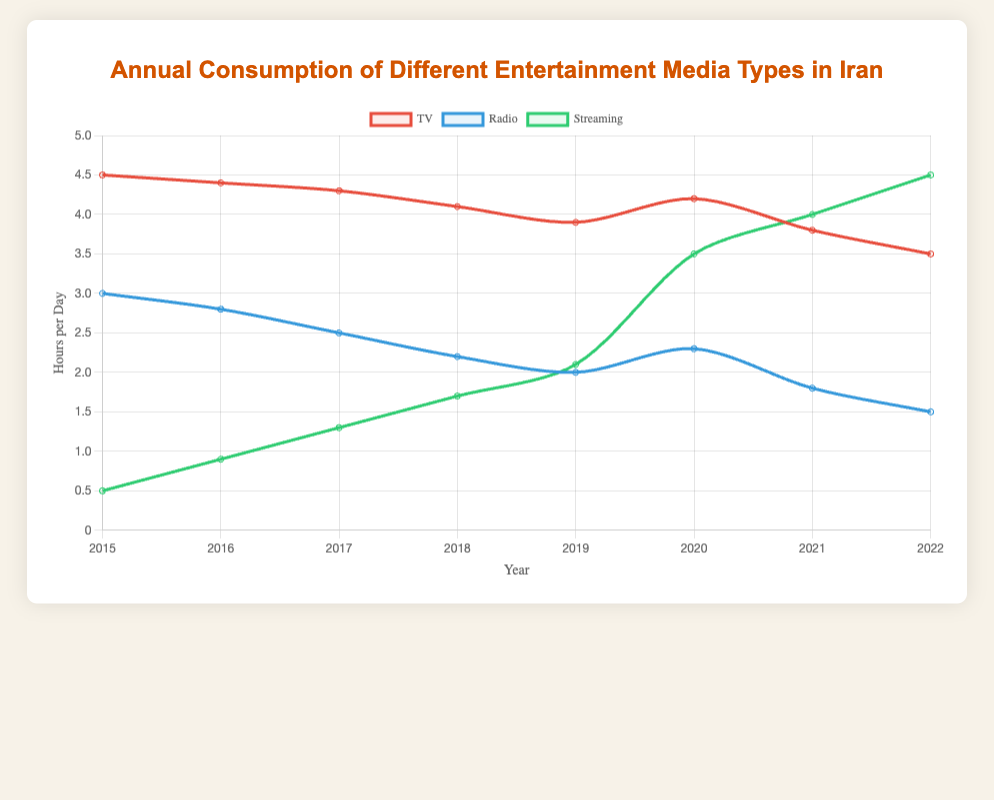what was the most consumed entertainment media type in 2015? Look at the plot for the year 2015 and compare the heights of the lines for TV, Radio, and Streaming. TV has the highest value.
Answer: TV how did TV consumption change from 2015 to 2022? Look at the TV consumption curve from 2015 to 2022. It starts at 4.5 hours per day in 2015 and decreases gradually to 3.5 hours per day in 2022.
Answer: decreased which year did Streaming consumption surpass TV consumption? Compare the curves for Streaming and TV. Streaming surpasses TV between 2019 and 2020. The first year when Streaming is higher than TV is in 2021.
Answer: 2021 compare Radio consumption in 2015 and 2022 Compare the values of the Radio curve for 2015 and 2022. Radio consumption decreases from 3.0 hours per day in 2015 to 1.5 hours per day in 2022.
Answer: decreased calculate the average annual consumption of Streaming from 2015 to 2022 Sum the values for Streaming from 2015 to 2022 and divide by the number of years (8): (0.5 + 0.9 + 1.3 + 1.7 + 2.1 + 3.5 + 4.0 + 4.5) / 8 = 2.3125.
Answer: 2.31 hours/day by how much did TV consumption increase from 2019 to 2020? Find the TV values for 2019 and 2020, then subtract the value for 2019 from the value for 2020: 4.2 - 3.9 = 0.3 hours/day.
Answer: 0.3 hours/day what was the overall trend for Radio consumption between 2015 and 2022? Observe the Radio curve from 2015 to 2022. The value consistently decreases from 3.0 hours per day in 2015 to 1.5 hours per day in 2022.
Answer: decreasing which year had the highest increase in Streaming consumption compared to the previous year? Calculate the yearly increase in Streaming consumption and find the highest increase: 0.9-0.5=0.4 (2016), 1.3-0.9=0.4 (2017), 1.7-1.3=0.4 (2018), 2.1-1.7=0.4 (2019), 3.5-2.1=1.4 (2020), 4.0-3.5=0.5 (2021), 4.5-4.0=0.5 (2022). The highest increase is in 2020.
Answer: 2020 